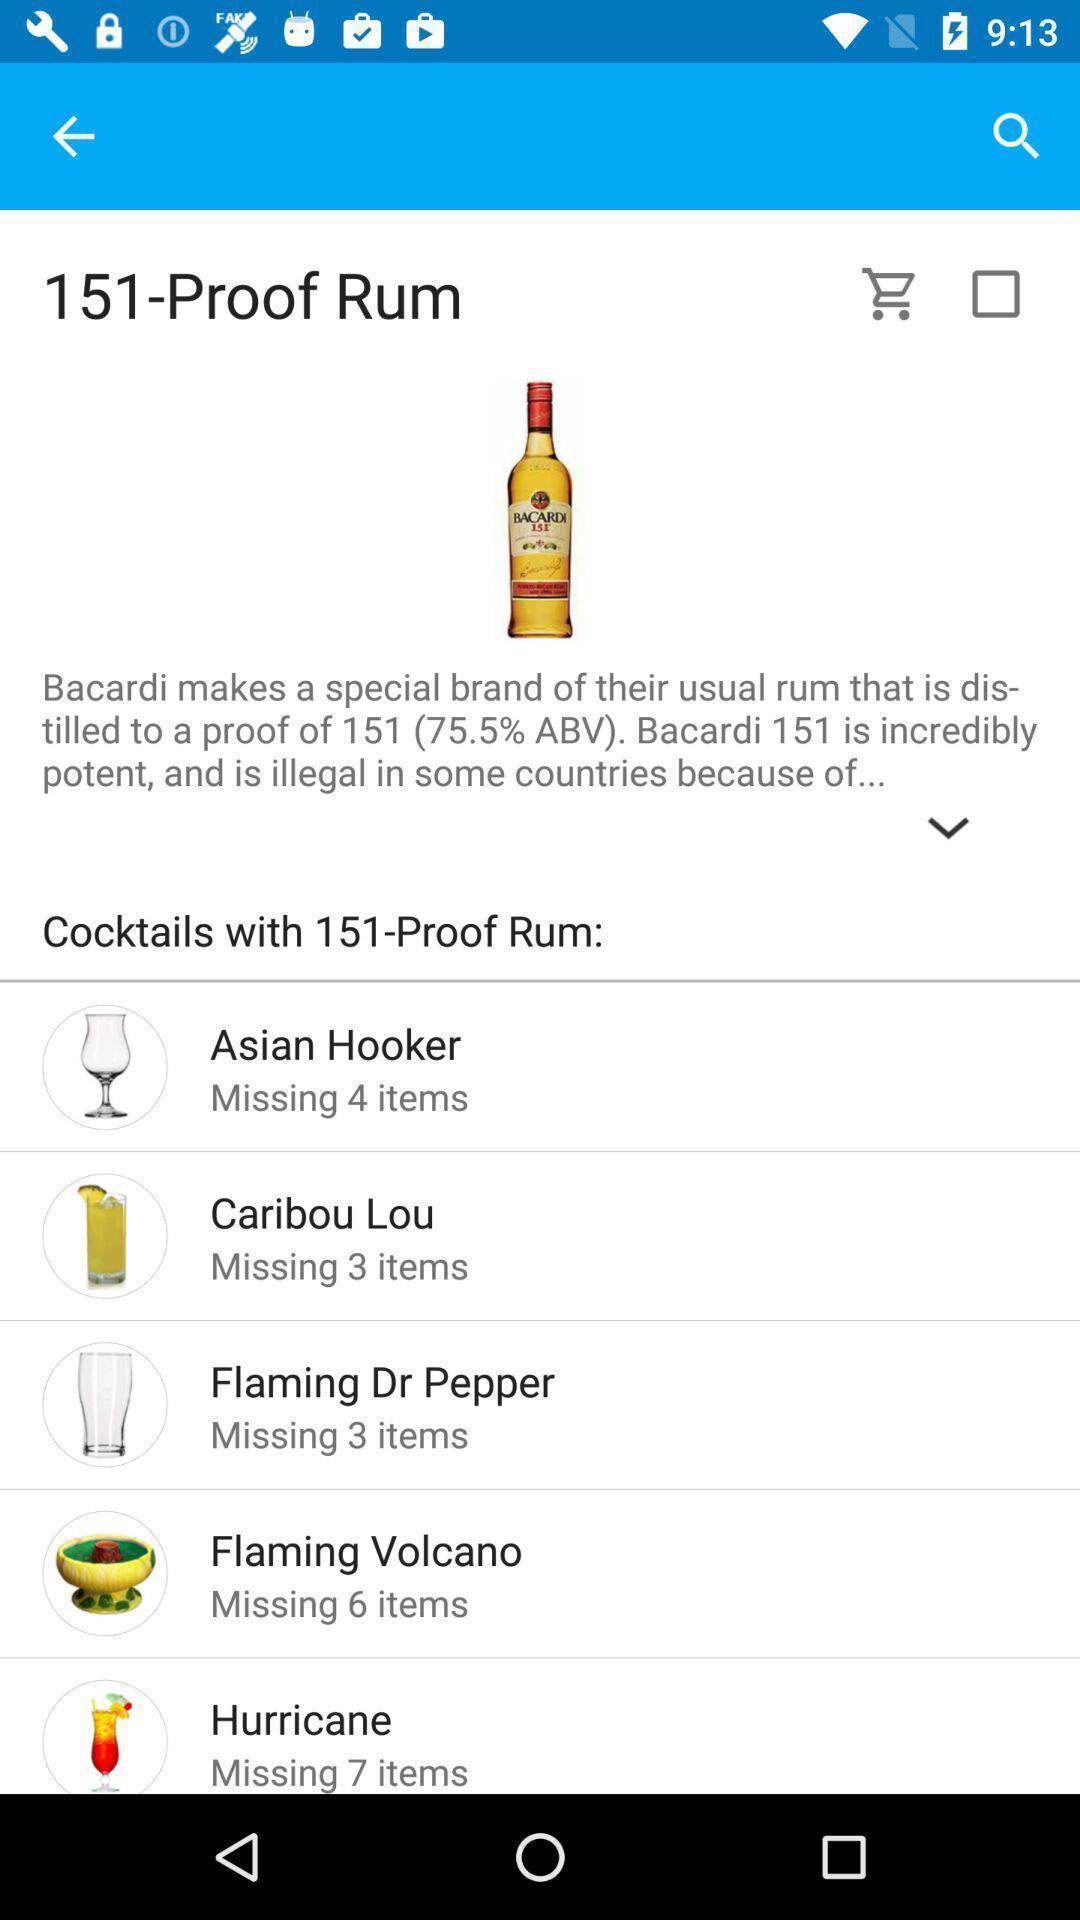What is the overall content of this screenshot? Various info displayed of a alcoholic beverage. 